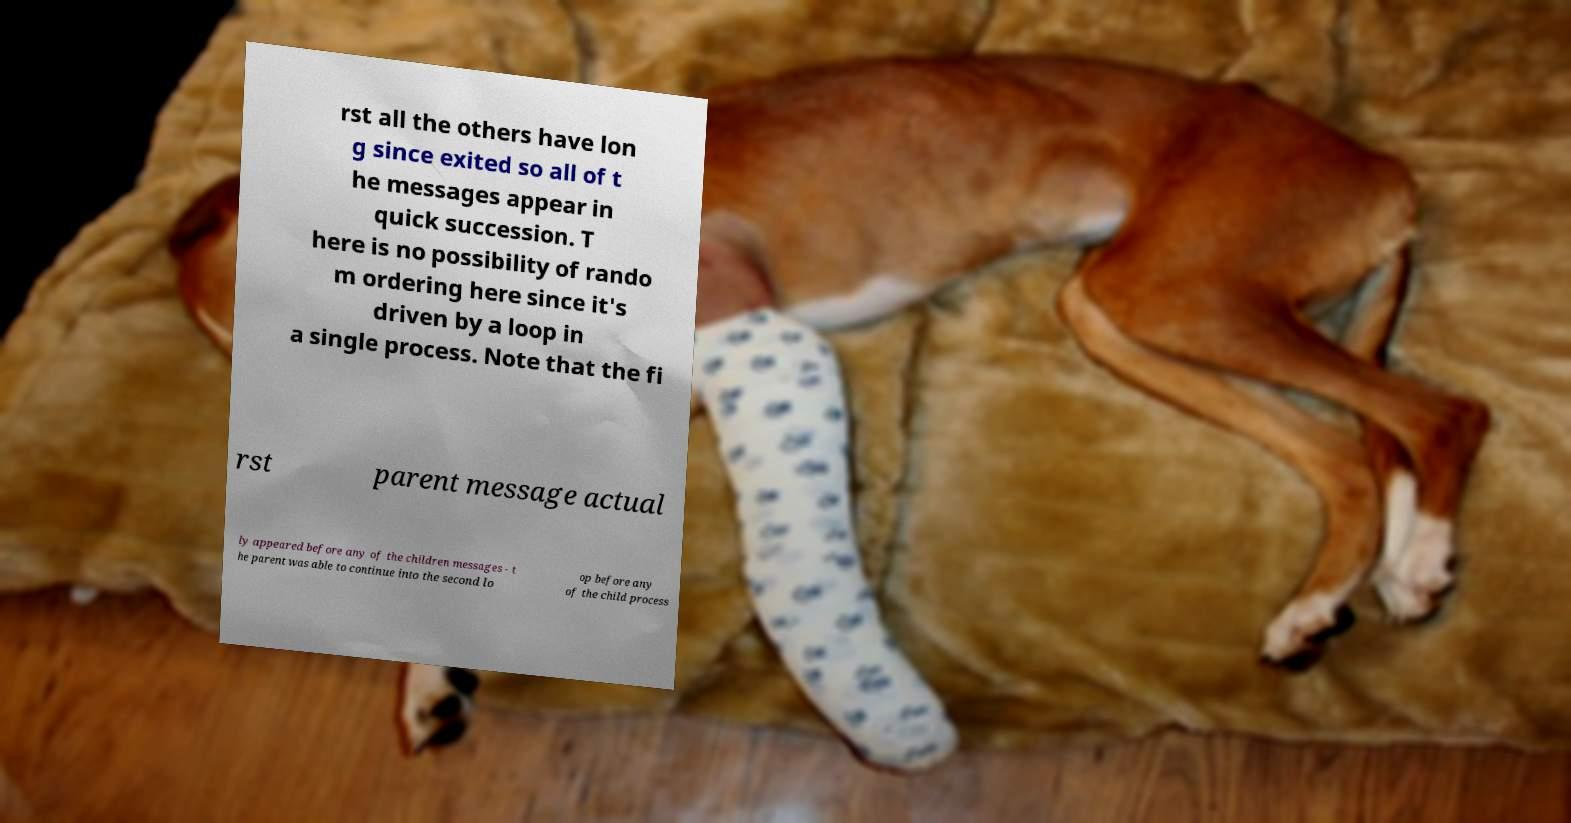Please identify and transcribe the text found in this image. rst all the others have lon g since exited so all of t he messages appear in quick succession. T here is no possibility of rando m ordering here since it's driven by a loop in a single process. Note that the fi rst parent message actual ly appeared before any of the children messages - t he parent was able to continue into the second lo op before any of the child process 